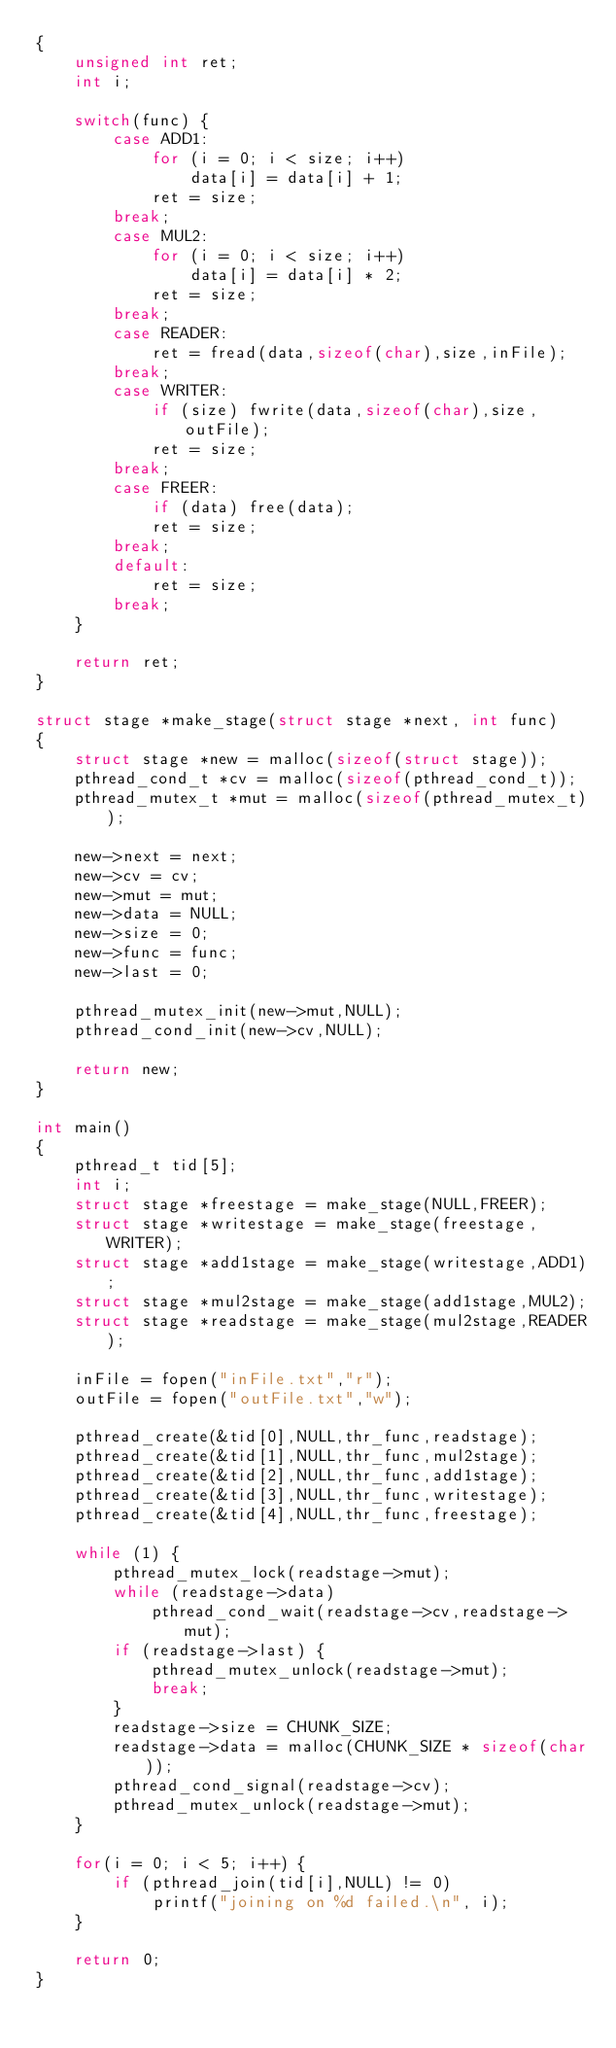<code> <loc_0><loc_0><loc_500><loc_500><_C_>{
    unsigned int ret;
    int i;

    switch(func) {
        case ADD1:
            for (i = 0; i < size; i++)
                data[i] = data[i] + 1;
            ret = size;
        break;
        case MUL2:
            for (i = 0; i < size; i++)
                data[i] = data[i] * 2;
            ret = size;
        break;
        case READER:
            ret = fread(data,sizeof(char),size,inFile);
        break;
        case WRITER:
            if (size) fwrite(data,sizeof(char),size,outFile);
            ret = size;
        break;
        case FREER:
            if (data) free(data);
            ret = size;
        break;
        default:
            ret = size;
        break;
    }

    return ret;
}

struct stage *make_stage(struct stage *next, int func)
{
    struct stage *new = malloc(sizeof(struct stage));
    pthread_cond_t *cv = malloc(sizeof(pthread_cond_t));
    pthread_mutex_t *mut = malloc(sizeof(pthread_mutex_t));

    new->next = next;
    new->cv = cv;
    new->mut = mut;
    new->data = NULL;
    new->size = 0;
    new->func = func;
    new->last = 0;

    pthread_mutex_init(new->mut,NULL);
    pthread_cond_init(new->cv,NULL);

    return new;
}

int main()
{
    pthread_t tid[5];
    int i;
    struct stage *freestage = make_stage(NULL,FREER);
    struct stage *writestage = make_stage(freestage,WRITER);
    struct stage *add1stage = make_stage(writestage,ADD1);
    struct stage *mul2stage = make_stage(add1stage,MUL2);
    struct stage *readstage = make_stage(mul2stage,READER);

    inFile = fopen("inFile.txt","r");
    outFile = fopen("outFile.txt","w");

    pthread_create(&tid[0],NULL,thr_func,readstage);
    pthread_create(&tid[1],NULL,thr_func,mul2stage);
    pthread_create(&tid[2],NULL,thr_func,add1stage);
    pthread_create(&tid[3],NULL,thr_func,writestage);
    pthread_create(&tid[4],NULL,thr_func,freestage);

    while (1) {
        pthread_mutex_lock(readstage->mut);
        while (readstage->data)
            pthread_cond_wait(readstage->cv,readstage->mut);
        if (readstage->last) {
            pthread_mutex_unlock(readstage->mut);
            break;
        }
        readstage->size = CHUNK_SIZE;
        readstage->data = malloc(CHUNK_SIZE * sizeof(char));
        pthread_cond_signal(readstage->cv);
        pthread_mutex_unlock(readstage->mut);
    }

    for(i = 0; i < 5; i++) {
        if (pthread_join(tid[i],NULL) != 0)
            printf("joining on %d failed.\n", i);
    }

    return 0;
}
</code> 